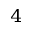Convert formula to latex. <formula><loc_0><loc_0><loc_500><loc_500>^ { 4 }</formula> 